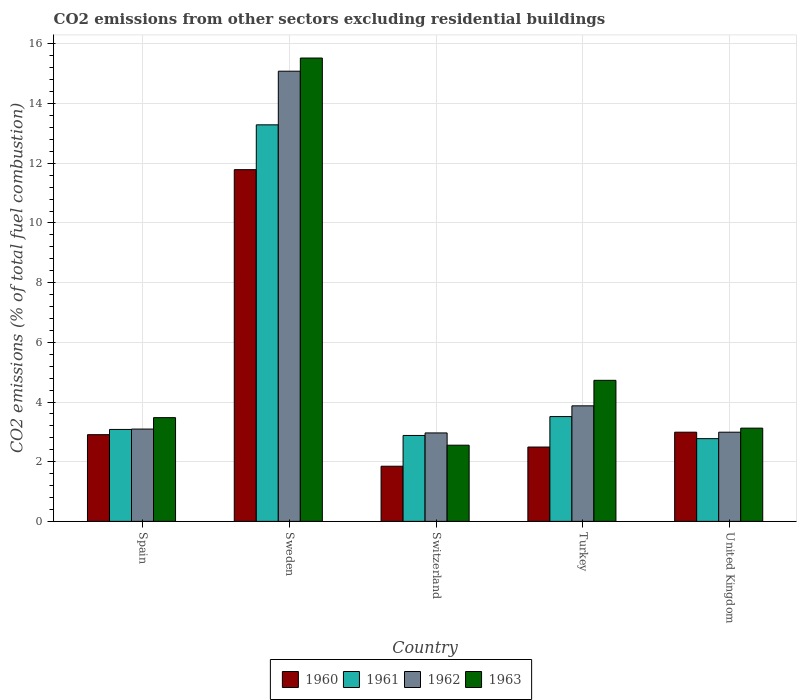How many groups of bars are there?
Your answer should be very brief. 5. Are the number of bars per tick equal to the number of legend labels?
Your response must be concise. Yes. Are the number of bars on each tick of the X-axis equal?
Give a very brief answer. Yes. How many bars are there on the 4th tick from the left?
Provide a short and direct response. 4. How many bars are there on the 2nd tick from the right?
Provide a short and direct response. 4. What is the label of the 1st group of bars from the left?
Provide a succinct answer. Spain. In how many cases, is the number of bars for a given country not equal to the number of legend labels?
Keep it short and to the point. 0. What is the total CO2 emitted in 1962 in Spain?
Ensure brevity in your answer.  3.09. Across all countries, what is the maximum total CO2 emitted in 1963?
Your answer should be compact. 15.53. Across all countries, what is the minimum total CO2 emitted in 1962?
Provide a succinct answer. 2.96. In which country was the total CO2 emitted in 1963 minimum?
Provide a succinct answer. Switzerland. What is the total total CO2 emitted in 1963 in the graph?
Your answer should be very brief. 29.41. What is the difference between the total CO2 emitted in 1962 in Spain and that in Switzerland?
Keep it short and to the point. 0.13. What is the difference between the total CO2 emitted in 1963 in United Kingdom and the total CO2 emitted in 1961 in Spain?
Ensure brevity in your answer.  0.04. What is the average total CO2 emitted in 1961 per country?
Your answer should be compact. 5.11. What is the difference between the total CO2 emitted of/in 1962 and total CO2 emitted of/in 1960 in United Kingdom?
Offer a very short reply. 1.3986663769838259e-5. In how many countries, is the total CO2 emitted in 1963 greater than 15.6?
Offer a very short reply. 0. What is the ratio of the total CO2 emitted in 1961 in Spain to that in United Kingdom?
Your answer should be very brief. 1.11. What is the difference between the highest and the second highest total CO2 emitted in 1961?
Offer a very short reply. -0.43. What is the difference between the highest and the lowest total CO2 emitted in 1963?
Provide a short and direct response. 12.97. In how many countries, is the total CO2 emitted in 1960 greater than the average total CO2 emitted in 1960 taken over all countries?
Provide a succinct answer. 1. What is the difference between two consecutive major ticks on the Y-axis?
Give a very brief answer. 2. Are the values on the major ticks of Y-axis written in scientific E-notation?
Keep it short and to the point. No. What is the title of the graph?
Your response must be concise. CO2 emissions from other sectors excluding residential buildings. What is the label or title of the X-axis?
Make the answer very short. Country. What is the label or title of the Y-axis?
Your answer should be very brief. CO2 emissions (% of total fuel combustion). What is the CO2 emissions (% of total fuel combustion) of 1960 in Spain?
Offer a very short reply. 2.91. What is the CO2 emissions (% of total fuel combustion) in 1961 in Spain?
Give a very brief answer. 3.08. What is the CO2 emissions (% of total fuel combustion) in 1962 in Spain?
Offer a very short reply. 3.09. What is the CO2 emissions (% of total fuel combustion) in 1963 in Spain?
Provide a short and direct response. 3.48. What is the CO2 emissions (% of total fuel combustion) in 1960 in Sweden?
Provide a succinct answer. 11.79. What is the CO2 emissions (% of total fuel combustion) in 1961 in Sweden?
Ensure brevity in your answer.  13.29. What is the CO2 emissions (% of total fuel combustion) in 1962 in Sweden?
Your response must be concise. 15.09. What is the CO2 emissions (% of total fuel combustion) in 1963 in Sweden?
Provide a short and direct response. 15.53. What is the CO2 emissions (% of total fuel combustion) of 1960 in Switzerland?
Make the answer very short. 1.85. What is the CO2 emissions (% of total fuel combustion) in 1961 in Switzerland?
Give a very brief answer. 2.88. What is the CO2 emissions (% of total fuel combustion) of 1962 in Switzerland?
Give a very brief answer. 2.96. What is the CO2 emissions (% of total fuel combustion) in 1963 in Switzerland?
Your answer should be very brief. 2.55. What is the CO2 emissions (% of total fuel combustion) of 1960 in Turkey?
Your response must be concise. 2.49. What is the CO2 emissions (% of total fuel combustion) of 1961 in Turkey?
Your answer should be very brief. 3.51. What is the CO2 emissions (% of total fuel combustion) of 1962 in Turkey?
Ensure brevity in your answer.  3.87. What is the CO2 emissions (% of total fuel combustion) of 1963 in Turkey?
Provide a short and direct response. 4.73. What is the CO2 emissions (% of total fuel combustion) of 1960 in United Kingdom?
Your answer should be compact. 2.99. What is the CO2 emissions (% of total fuel combustion) of 1961 in United Kingdom?
Provide a short and direct response. 2.77. What is the CO2 emissions (% of total fuel combustion) of 1962 in United Kingdom?
Offer a very short reply. 2.99. What is the CO2 emissions (% of total fuel combustion) of 1963 in United Kingdom?
Provide a succinct answer. 3.12. Across all countries, what is the maximum CO2 emissions (% of total fuel combustion) in 1960?
Your answer should be very brief. 11.79. Across all countries, what is the maximum CO2 emissions (% of total fuel combustion) in 1961?
Give a very brief answer. 13.29. Across all countries, what is the maximum CO2 emissions (% of total fuel combustion) in 1962?
Your answer should be compact. 15.09. Across all countries, what is the maximum CO2 emissions (% of total fuel combustion) of 1963?
Your answer should be very brief. 15.53. Across all countries, what is the minimum CO2 emissions (% of total fuel combustion) in 1960?
Make the answer very short. 1.85. Across all countries, what is the minimum CO2 emissions (% of total fuel combustion) in 1961?
Offer a terse response. 2.77. Across all countries, what is the minimum CO2 emissions (% of total fuel combustion) in 1962?
Your response must be concise. 2.96. Across all countries, what is the minimum CO2 emissions (% of total fuel combustion) in 1963?
Keep it short and to the point. 2.55. What is the total CO2 emissions (% of total fuel combustion) in 1960 in the graph?
Give a very brief answer. 22.02. What is the total CO2 emissions (% of total fuel combustion) in 1961 in the graph?
Your answer should be very brief. 25.53. What is the total CO2 emissions (% of total fuel combustion) of 1962 in the graph?
Give a very brief answer. 28. What is the total CO2 emissions (% of total fuel combustion) in 1963 in the graph?
Offer a very short reply. 29.41. What is the difference between the CO2 emissions (% of total fuel combustion) of 1960 in Spain and that in Sweden?
Give a very brief answer. -8.88. What is the difference between the CO2 emissions (% of total fuel combustion) in 1961 in Spain and that in Sweden?
Provide a short and direct response. -10.21. What is the difference between the CO2 emissions (% of total fuel combustion) of 1962 in Spain and that in Sweden?
Ensure brevity in your answer.  -11.99. What is the difference between the CO2 emissions (% of total fuel combustion) in 1963 in Spain and that in Sweden?
Offer a terse response. -12.05. What is the difference between the CO2 emissions (% of total fuel combustion) of 1960 in Spain and that in Switzerland?
Keep it short and to the point. 1.06. What is the difference between the CO2 emissions (% of total fuel combustion) in 1961 in Spain and that in Switzerland?
Provide a succinct answer. 0.2. What is the difference between the CO2 emissions (% of total fuel combustion) in 1962 in Spain and that in Switzerland?
Make the answer very short. 0.13. What is the difference between the CO2 emissions (% of total fuel combustion) of 1963 in Spain and that in Switzerland?
Your response must be concise. 0.92. What is the difference between the CO2 emissions (% of total fuel combustion) of 1960 in Spain and that in Turkey?
Provide a succinct answer. 0.41. What is the difference between the CO2 emissions (% of total fuel combustion) in 1961 in Spain and that in Turkey?
Provide a short and direct response. -0.43. What is the difference between the CO2 emissions (% of total fuel combustion) of 1962 in Spain and that in Turkey?
Give a very brief answer. -0.78. What is the difference between the CO2 emissions (% of total fuel combustion) of 1963 in Spain and that in Turkey?
Your answer should be very brief. -1.25. What is the difference between the CO2 emissions (% of total fuel combustion) of 1960 in Spain and that in United Kingdom?
Provide a succinct answer. -0.08. What is the difference between the CO2 emissions (% of total fuel combustion) of 1961 in Spain and that in United Kingdom?
Provide a short and direct response. 0.31. What is the difference between the CO2 emissions (% of total fuel combustion) of 1962 in Spain and that in United Kingdom?
Offer a terse response. 0.1. What is the difference between the CO2 emissions (% of total fuel combustion) in 1963 in Spain and that in United Kingdom?
Offer a very short reply. 0.35. What is the difference between the CO2 emissions (% of total fuel combustion) of 1960 in Sweden and that in Switzerland?
Keep it short and to the point. 9.94. What is the difference between the CO2 emissions (% of total fuel combustion) in 1961 in Sweden and that in Switzerland?
Your response must be concise. 10.41. What is the difference between the CO2 emissions (% of total fuel combustion) in 1962 in Sweden and that in Switzerland?
Give a very brief answer. 12.12. What is the difference between the CO2 emissions (% of total fuel combustion) in 1963 in Sweden and that in Switzerland?
Offer a very short reply. 12.97. What is the difference between the CO2 emissions (% of total fuel combustion) in 1960 in Sweden and that in Turkey?
Keep it short and to the point. 9.3. What is the difference between the CO2 emissions (% of total fuel combustion) of 1961 in Sweden and that in Turkey?
Offer a very short reply. 9.78. What is the difference between the CO2 emissions (% of total fuel combustion) in 1962 in Sweden and that in Turkey?
Keep it short and to the point. 11.21. What is the difference between the CO2 emissions (% of total fuel combustion) of 1963 in Sweden and that in Turkey?
Make the answer very short. 10.8. What is the difference between the CO2 emissions (% of total fuel combustion) in 1960 in Sweden and that in United Kingdom?
Keep it short and to the point. 8.8. What is the difference between the CO2 emissions (% of total fuel combustion) of 1961 in Sweden and that in United Kingdom?
Provide a short and direct response. 10.52. What is the difference between the CO2 emissions (% of total fuel combustion) of 1962 in Sweden and that in United Kingdom?
Provide a short and direct response. 12.1. What is the difference between the CO2 emissions (% of total fuel combustion) of 1963 in Sweden and that in United Kingdom?
Your answer should be very brief. 12.4. What is the difference between the CO2 emissions (% of total fuel combustion) in 1960 in Switzerland and that in Turkey?
Your response must be concise. -0.64. What is the difference between the CO2 emissions (% of total fuel combustion) of 1961 in Switzerland and that in Turkey?
Provide a succinct answer. -0.63. What is the difference between the CO2 emissions (% of total fuel combustion) in 1962 in Switzerland and that in Turkey?
Ensure brevity in your answer.  -0.91. What is the difference between the CO2 emissions (% of total fuel combustion) of 1963 in Switzerland and that in Turkey?
Give a very brief answer. -2.17. What is the difference between the CO2 emissions (% of total fuel combustion) in 1960 in Switzerland and that in United Kingdom?
Give a very brief answer. -1.14. What is the difference between the CO2 emissions (% of total fuel combustion) of 1961 in Switzerland and that in United Kingdom?
Offer a terse response. 0.11. What is the difference between the CO2 emissions (% of total fuel combustion) of 1962 in Switzerland and that in United Kingdom?
Ensure brevity in your answer.  -0.02. What is the difference between the CO2 emissions (% of total fuel combustion) of 1963 in Switzerland and that in United Kingdom?
Provide a succinct answer. -0.57. What is the difference between the CO2 emissions (% of total fuel combustion) in 1960 in Turkey and that in United Kingdom?
Your answer should be very brief. -0.5. What is the difference between the CO2 emissions (% of total fuel combustion) of 1961 in Turkey and that in United Kingdom?
Provide a short and direct response. 0.74. What is the difference between the CO2 emissions (% of total fuel combustion) in 1962 in Turkey and that in United Kingdom?
Make the answer very short. 0.88. What is the difference between the CO2 emissions (% of total fuel combustion) of 1963 in Turkey and that in United Kingdom?
Give a very brief answer. 1.6. What is the difference between the CO2 emissions (% of total fuel combustion) of 1960 in Spain and the CO2 emissions (% of total fuel combustion) of 1961 in Sweden?
Your answer should be compact. -10.38. What is the difference between the CO2 emissions (% of total fuel combustion) in 1960 in Spain and the CO2 emissions (% of total fuel combustion) in 1962 in Sweden?
Make the answer very short. -12.18. What is the difference between the CO2 emissions (% of total fuel combustion) of 1960 in Spain and the CO2 emissions (% of total fuel combustion) of 1963 in Sweden?
Offer a terse response. -12.62. What is the difference between the CO2 emissions (% of total fuel combustion) in 1961 in Spain and the CO2 emissions (% of total fuel combustion) in 1962 in Sweden?
Keep it short and to the point. -12.01. What is the difference between the CO2 emissions (% of total fuel combustion) in 1961 in Spain and the CO2 emissions (% of total fuel combustion) in 1963 in Sweden?
Offer a terse response. -12.45. What is the difference between the CO2 emissions (% of total fuel combustion) of 1962 in Spain and the CO2 emissions (% of total fuel combustion) of 1963 in Sweden?
Make the answer very short. -12.43. What is the difference between the CO2 emissions (% of total fuel combustion) in 1960 in Spain and the CO2 emissions (% of total fuel combustion) in 1961 in Switzerland?
Provide a short and direct response. 0.03. What is the difference between the CO2 emissions (% of total fuel combustion) in 1960 in Spain and the CO2 emissions (% of total fuel combustion) in 1962 in Switzerland?
Provide a short and direct response. -0.06. What is the difference between the CO2 emissions (% of total fuel combustion) of 1960 in Spain and the CO2 emissions (% of total fuel combustion) of 1963 in Switzerland?
Ensure brevity in your answer.  0.35. What is the difference between the CO2 emissions (% of total fuel combustion) in 1961 in Spain and the CO2 emissions (% of total fuel combustion) in 1962 in Switzerland?
Your answer should be very brief. 0.12. What is the difference between the CO2 emissions (% of total fuel combustion) of 1961 in Spain and the CO2 emissions (% of total fuel combustion) of 1963 in Switzerland?
Offer a terse response. 0.53. What is the difference between the CO2 emissions (% of total fuel combustion) in 1962 in Spain and the CO2 emissions (% of total fuel combustion) in 1963 in Switzerland?
Make the answer very short. 0.54. What is the difference between the CO2 emissions (% of total fuel combustion) of 1960 in Spain and the CO2 emissions (% of total fuel combustion) of 1961 in Turkey?
Your answer should be compact. -0.61. What is the difference between the CO2 emissions (% of total fuel combustion) of 1960 in Spain and the CO2 emissions (% of total fuel combustion) of 1962 in Turkey?
Your answer should be compact. -0.97. What is the difference between the CO2 emissions (% of total fuel combustion) in 1960 in Spain and the CO2 emissions (% of total fuel combustion) in 1963 in Turkey?
Offer a very short reply. -1.82. What is the difference between the CO2 emissions (% of total fuel combustion) of 1961 in Spain and the CO2 emissions (% of total fuel combustion) of 1962 in Turkey?
Keep it short and to the point. -0.79. What is the difference between the CO2 emissions (% of total fuel combustion) in 1961 in Spain and the CO2 emissions (% of total fuel combustion) in 1963 in Turkey?
Provide a succinct answer. -1.65. What is the difference between the CO2 emissions (% of total fuel combustion) in 1962 in Spain and the CO2 emissions (% of total fuel combustion) in 1963 in Turkey?
Provide a short and direct response. -1.63. What is the difference between the CO2 emissions (% of total fuel combustion) in 1960 in Spain and the CO2 emissions (% of total fuel combustion) in 1961 in United Kingdom?
Provide a short and direct response. 0.13. What is the difference between the CO2 emissions (% of total fuel combustion) in 1960 in Spain and the CO2 emissions (% of total fuel combustion) in 1962 in United Kingdom?
Ensure brevity in your answer.  -0.08. What is the difference between the CO2 emissions (% of total fuel combustion) of 1960 in Spain and the CO2 emissions (% of total fuel combustion) of 1963 in United Kingdom?
Your answer should be very brief. -0.22. What is the difference between the CO2 emissions (% of total fuel combustion) of 1961 in Spain and the CO2 emissions (% of total fuel combustion) of 1962 in United Kingdom?
Offer a very short reply. 0.09. What is the difference between the CO2 emissions (% of total fuel combustion) in 1961 in Spain and the CO2 emissions (% of total fuel combustion) in 1963 in United Kingdom?
Your answer should be very brief. -0.04. What is the difference between the CO2 emissions (% of total fuel combustion) of 1962 in Spain and the CO2 emissions (% of total fuel combustion) of 1963 in United Kingdom?
Your answer should be compact. -0.03. What is the difference between the CO2 emissions (% of total fuel combustion) in 1960 in Sweden and the CO2 emissions (% of total fuel combustion) in 1961 in Switzerland?
Keep it short and to the point. 8.91. What is the difference between the CO2 emissions (% of total fuel combustion) of 1960 in Sweden and the CO2 emissions (% of total fuel combustion) of 1962 in Switzerland?
Keep it short and to the point. 8.82. What is the difference between the CO2 emissions (% of total fuel combustion) of 1960 in Sweden and the CO2 emissions (% of total fuel combustion) of 1963 in Switzerland?
Keep it short and to the point. 9.23. What is the difference between the CO2 emissions (% of total fuel combustion) in 1961 in Sweden and the CO2 emissions (% of total fuel combustion) in 1962 in Switzerland?
Provide a short and direct response. 10.32. What is the difference between the CO2 emissions (% of total fuel combustion) in 1961 in Sweden and the CO2 emissions (% of total fuel combustion) in 1963 in Switzerland?
Provide a short and direct response. 10.74. What is the difference between the CO2 emissions (% of total fuel combustion) in 1962 in Sweden and the CO2 emissions (% of total fuel combustion) in 1963 in Switzerland?
Keep it short and to the point. 12.53. What is the difference between the CO2 emissions (% of total fuel combustion) in 1960 in Sweden and the CO2 emissions (% of total fuel combustion) in 1961 in Turkey?
Offer a very short reply. 8.27. What is the difference between the CO2 emissions (% of total fuel combustion) in 1960 in Sweden and the CO2 emissions (% of total fuel combustion) in 1962 in Turkey?
Your answer should be very brief. 7.91. What is the difference between the CO2 emissions (% of total fuel combustion) of 1960 in Sweden and the CO2 emissions (% of total fuel combustion) of 1963 in Turkey?
Provide a succinct answer. 7.06. What is the difference between the CO2 emissions (% of total fuel combustion) of 1961 in Sweden and the CO2 emissions (% of total fuel combustion) of 1962 in Turkey?
Offer a terse response. 9.42. What is the difference between the CO2 emissions (% of total fuel combustion) of 1961 in Sweden and the CO2 emissions (% of total fuel combustion) of 1963 in Turkey?
Offer a terse response. 8.56. What is the difference between the CO2 emissions (% of total fuel combustion) of 1962 in Sweden and the CO2 emissions (% of total fuel combustion) of 1963 in Turkey?
Offer a very short reply. 10.36. What is the difference between the CO2 emissions (% of total fuel combustion) in 1960 in Sweden and the CO2 emissions (% of total fuel combustion) in 1961 in United Kingdom?
Your answer should be compact. 9.01. What is the difference between the CO2 emissions (% of total fuel combustion) in 1960 in Sweden and the CO2 emissions (% of total fuel combustion) in 1962 in United Kingdom?
Your answer should be compact. 8.8. What is the difference between the CO2 emissions (% of total fuel combustion) of 1960 in Sweden and the CO2 emissions (% of total fuel combustion) of 1963 in United Kingdom?
Ensure brevity in your answer.  8.66. What is the difference between the CO2 emissions (% of total fuel combustion) of 1961 in Sweden and the CO2 emissions (% of total fuel combustion) of 1962 in United Kingdom?
Ensure brevity in your answer.  10.3. What is the difference between the CO2 emissions (% of total fuel combustion) of 1961 in Sweden and the CO2 emissions (% of total fuel combustion) of 1963 in United Kingdom?
Give a very brief answer. 10.16. What is the difference between the CO2 emissions (% of total fuel combustion) in 1962 in Sweden and the CO2 emissions (% of total fuel combustion) in 1963 in United Kingdom?
Give a very brief answer. 11.96. What is the difference between the CO2 emissions (% of total fuel combustion) in 1960 in Switzerland and the CO2 emissions (% of total fuel combustion) in 1961 in Turkey?
Offer a very short reply. -1.66. What is the difference between the CO2 emissions (% of total fuel combustion) in 1960 in Switzerland and the CO2 emissions (% of total fuel combustion) in 1962 in Turkey?
Ensure brevity in your answer.  -2.02. What is the difference between the CO2 emissions (% of total fuel combustion) in 1960 in Switzerland and the CO2 emissions (% of total fuel combustion) in 1963 in Turkey?
Offer a very short reply. -2.88. What is the difference between the CO2 emissions (% of total fuel combustion) in 1961 in Switzerland and the CO2 emissions (% of total fuel combustion) in 1962 in Turkey?
Give a very brief answer. -0.99. What is the difference between the CO2 emissions (% of total fuel combustion) in 1961 in Switzerland and the CO2 emissions (% of total fuel combustion) in 1963 in Turkey?
Keep it short and to the point. -1.85. What is the difference between the CO2 emissions (% of total fuel combustion) in 1962 in Switzerland and the CO2 emissions (% of total fuel combustion) in 1963 in Turkey?
Your response must be concise. -1.76. What is the difference between the CO2 emissions (% of total fuel combustion) of 1960 in Switzerland and the CO2 emissions (% of total fuel combustion) of 1961 in United Kingdom?
Ensure brevity in your answer.  -0.92. What is the difference between the CO2 emissions (% of total fuel combustion) of 1960 in Switzerland and the CO2 emissions (% of total fuel combustion) of 1962 in United Kingdom?
Make the answer very short. -1.14. What is the difference between the CO2 emissions (% of total fuel combustion) in 1960 in Switzerland and the CO2 emissions (% of total fuel combustion) in 1963 in United Kingdom?
Your answer should be compact. -1.28. What is the difference between the CO2 emissions (% of total fuel combustion) of 1961 in Switzerland and the CO2 emissions (% of total fuel combustion) of 1962 in United Kingdom?
Ensure brevity in your answer.  -0.11. What is the difference between the CO2 emissions (% of total fuel combustion) in 1961 in Switzerland and the CO2 emissions (% of total fuel combustion) in 1963 in United Kingdom?
Make the answer very short. -0.25. What is the difference between the CO2 emissions (% of total fuel combustion) in 1962 in Switzerland and the CO2 emissions (% of total fuel combustion) in 1963 in United Kingdom?
Give a very brief answer. -0.16. What is the difference between the CO2 emissions (% of total fuel combustion) of 1960 in Turkey and the CO2 emissions (% of total fuel combustion) of 1961 in United Kingdom?
Offer a very short reply. -0.28. What is the difference between the CO2 emissions (% of total fuel combustion) in 1960 in Turkey and the CO2 emissions (% of total fuel combustion) in 1962 in United Kingdom?
Make the answer very short. -0.5. What is the difference between the CO2 emissions (% of total fuel combustion) in 1960 in Turkey and the CO2 emissions (% of total fuel combustion) in 1963 in United Kingdom?
Offer a very short reply. -0.63. What is the difference between the CO2 emissions (% of total fuel combustion) in 1961 in Turkey and the CO2 emissions (% of total fuel combustion) in 1962 in United Kingdom?
Offer a very short reply. 0.52. What is the difference between the CO2 emissions (% of total fuel combustion) of 1961 in Turkey and the CO2 emissions (% of total fuel combustion) of 1963 in United Kingdom?
Your answer should be compact. 0.39. What is the difference between the CO2 emissions (% of total fuel combustion) of 1962 in Turkey and the CO2 emissions (% of total fuel combustion) of 1963 in United Kingdom?
Offer a very short reply. 0.75. What is the average CO2 emissions (% of total fuel combustion) of 1960 per country?
Keep it short and to the point. 4.4. What is the average CO2 emissions (% of total fuel combustion) in 1961 per country?
Keep it short and to the point. 5.11. What is the average CO2 emissions (% of total fuel combustion) in 1962 per country?
Give a very brief answer. 5.6. What is the average CO2 emissions (% of total fuel combustion) in 1963 per country?
Give a very brief answer. 5.88. What is the difference between the CO2 emissions (% of total fuel combustion) in 1960 and CO2 emissions (% of total fuel combustion) in 1961 in Spain?
Your answer should be compact. -0.17. What is the difference between the CO2 emissions (% of total fuel combustion) in 1960 and CO2 emissions (% of total fuel combustion) in 1962 in Spain?
Provide a succinct answer. -0.19. What is the difference between the CO2 emissions (% of total fuel combustion) of 1960 and CO2 emissions (% of total fuel combustion) of 1963 in Spain?
Your response must be concise. -0.57. What is the difference between the CO2 emissions (% of total fuel combustion) in 1961 and CO2 emissions (% of total fuel combustion) in 1962 in Spain?
Make the answer very short. -0.01. What is the difference between the CO2 emissions (% of total fuel combustion) of 1961 and CO2 emissions (% of total fuel combustion) of 1963 in Spain?
Make the answer very short. -0.4. What is the difference between the CO2 emissions (% of total fuel combustion) of 1962 and CO2 emissions (% of total fuel combustion) of 1963 in Spain?
Give a very brief answer. -0.38. What is the difference between the CO2 emissions (% of total fuel combustion) in 1960 and CO2 emissions (% of total fuel combustion) in 1961 in Sweden?
Your response must be concise. -1.5. What is the difference between the CO2 emissions (% of total fuel combustion) in 1960 and CO2 emissions (% of total fuel combustion) in 1962 in Sweden?
Your answer should be very brief. -3.3. What is the difference between the CO2 emissions (% of total fuel combustion) in 1960 and CO2 emissions (% of total fuel combustion) in 1963 in Sweden?
Keep it short and to the point. -3.74. What is the difference between the CO2 emissions (% of total fuel combustion) of 1961 and CO2 emissions (% of total fuel combustion) of 1962 in Sweden?
Your answer should be very brief. -1.8. What is the difference between the CO2 emissions (% of total fuel combustion) in 1961 and CO2 emissions (% of total fuel combustion) in 1963 in Sweden?
Provide a short and direct response. -2.24. What is the difference between the CO2 emissions (% of total fuel combustion) of 1962 and CO2 emissions (% of total fuel combustion) of 1963 in Sweden?
Your answer should be compact. -0.44. What is the difference between the CO2 emissions (% of total fuel combustion) in 1960 and CO2 emissions (% of total fuel combustion) in 1961 in Switzerland?
Offer a terse response. -1.03. What is the difference between the CO2 emissions (% of total fuel combustion) of 1960 and CO2 emissions (% of total fuel combustion) of 1962 in Switzerland?
Your answer should be compact. -1.12. What is the difference between the CO2 emissions (% of total fuel combustion) of 1960 and CO2 emissions (% of total fuel combustion) of 1963 in Switzerland?
Give a very brief answer. -0.7. What is the difference between the CO2 emissions (% of total fuel combustion) in 1961 and CO2 emissions (% of total fuel combustion) in 1962 in Switzerland?
Offer a very short reply. -0.08. What is the difference between the CO2 emissions (% of total fuel combustion) of 1961 and CO2 emissions (% of total fuel combustion) of 1963 in Switzerland?
Offer a terse response. 0.33. What is the difference between the CO2 emissions (% of total fuel combustion) of 1962 and CO2 emissions (% of total fuel combustion) of 1963 in Switzerland?
Make the answer very short. 0.41. What is the difference between the CO2 emissions (% of total fuel combustion) of 1960 and CO2 emissions (% of total fuel combustion) of 1961 in Turkey?
Keep it short and to the point. -1.02. What is the difference between the CO2 emissions (% of total fuel combustion) of 1960 and CO2 emissions (% of total fuel combustion) of 1962 in Turkey?
Provide a succinct answer. -1.38. What is the difference between the CO2 emissions (% of total fuel combustion) in 1960 and CO2 emissions (% of total fuel combustion) in 1963 in Turkey?
Make the answer very short. -2.24. What is the difference between the CO2 emissions (% of total fuel combustion) of 1961 and CO2 emissions (% of total fuel combustion) of 1962 in Turkey?
Your answer should be compact. -0.36. What is the difference between the CO2 emissions (% of total fuel combustion) of 1961 and CO2 emissions (% of total fuel combustion) of 1963 in Turkey?
Give a very brief answer. -1.21. What is the difference between the CO2 emissions (% of total fuel combustion) of 1962 and CO2 emissions (% of total fuel combustion) of 1963 in Turkey?
Provide a succinct answer. -0.85. What is the difference between the CO2 emissions (% of total fuel combustion) of 1960 and CO2 emissions (% of total fuel combustion) of 1961 in United Kingdom?
Your answer should be very brief. 0.22. What is the difference between the CO2 emissions (% of total fuel combustion) in 1960 and CO2 emissions (% of total fuel combustion) in 1963 in United Kingdom?
Provide a succinct answer. -0.14. What is the difference between the CO2 emissions (% of total fuel combustion) in 1961 and CO2 emissions (% of total fuel combustion) in 1962 in United Kingdom?
Provide a short and direct response. -0.22. What is the difference between the CO2 emissions (% of total fuel combustion) of 1961 and CO2 emissions (% of total fuel combustion) of 1963 in United Kingdom?
Ensure brevity in your answer.  -0.35. What is the difference between the CO2 emissions (% of total fuel combustion) in 1962 and CO2 emissions (% of total fuel combustion) in 1963 in United Kingdom?
Your response must be concise. -0.14. What is the ratio of the CO2 emissions (% of total fuel combustion) of 1960 in Spain to that in Sweden?
Provide a short and direct response. 0.25. What is the ratio of the CO2 emissions (% of total fuel combustion) of 1961 in Spain to that in Sweden?
Make the answer very short. 0.23. What is the ratio of the CO2 emissions (% of total fuel combustion) in 1962 in Spain to that in Sweden?
Give a very brief answer. 0.2. What is the ratio of the CO2 emissions (% of total fuel combustion) in 1963 in Spain to that in Sweden?
Provide a succinct answer. 0.22. What is the ratio of the CO2 emissions (% of total fuel combustion) in 1960 in Spain to that in Switzerland?
Keep it short and to the point. 1.57. What is the ratio of the CO2 emissions (% of total fuel combustion) in 1961 in Spain to that in Switzerland?
Offer a terse response. 1.07. What is the ratio of the CO2 emissions (% of total fuel combustion) of 1962 in Spain to that in Switzerland?
Keep it short and to the point. 1.04. What is the ratio of the CO2 emissions (% of total fuel combustion) of 1963 in Spain to that in Switzerland?
Give a very brief answer. 1.36. What is the ratio of the CO2 emissions (% of total fuel combustion) in 1960 in Spain to that in Turkey?
Ensure brevity in your answer.  1.17. What is the ratio of the CO2 emissions (% of total fuel combustion) in 1961 in Spain to that in Turkey?
Offer a very short reply. 0.88. What is the ratio of the CO2 emissions (% of total fuel combustion) of 1962 in Spain to that in Turkey?
Your answer should be compact. 0.8. What is the ratio of the CO2 emissions (% of total fuel combustion) in 1963 in Spain to that in Turkey?
Offer a very short reply. 0.74. What is the ratio of the CO2 emissions (% of total fuel combustion) in 1960 in Spain to that in United Kingdom?
Give a very brief answer. 0.97. What is the ratio of the CO2 emissions (% of total fuel combustion) in 1961 in Spain to that in United Kingdom?
Provide a succinct answer. 1.11. What is the ratio of the CO2 emissions (% of total fuel combustion) of 1962 in Spain to that in United Kingdom?
Ensure brevity in your answer.  1.03. What is the ratio of the CO2 emissions (% of total fuel combustion) in 1963 in Spain to that in United Kingdom?
Keep it short and to the point. 1.11. What is the ratio of the CO2 emissions (% of total fuel combustion) of 1960 in Sweden to that in Switzerland?
Make the answer very short. 6.38. What is the ratio of the CO2 emissions (% of total fuel combustion) of 1961 in Sweden to that in Switzerland?
Give a very brief answer. 4.62. What is the ratio of the CO2 emissions (% of total fuel combustion) in 1962 in Sweden to that in Switzerland?
Provide a succinct answer. 5.09. What is the ratio of the CO2 emissions (% of total fuel combustion) of 1963 in Sweden to that in Switzerland?
Your response must be concise. 6.08. What is the ratio of the CO2 emissions (% of total fuel combustion) in 1960 in Sweden to that in Turkey?
Make the answer very short. 4.73. What is the ratio of the CO2 emissions (% of total fuel combustion) in 1961 in Sweden to that in Turkey?
Give a very brief answer. 3.78. What is the ratio of the CO2 emissions (% of total fuel combustion) in 1962 in Sweden to that in Turkey?
Make the answer very short. 3.9. What is the ratio of the CO2 emissions (% of total fuel combustion) in 1963 in Sweden to that in Turkey?
Provide a short and direct response. 3.29. What is the ratio of the CO2 emissions (% of total fuel combustion) of 1960 in Sweden to that in United Kingdom?
Your answer should be compact. 3.94. What is the ratio of the CO2 emissions (% of total fuel combustion) in 1961 in Sweden to that in United Kingdom?
Give a very brief answer. 4.79. What is the ratio of the CO2 emissions (% of total fuel combustion) of 1962 in Sweden to that in United Kingdom?
Ensure brevity in your answer.  5.05. What is the ratio of the CO2 emissions (% of total fuel combustion) of 1963 in Sweden to that in United Kingdom?
Offer a very short reply. 4.97. What is the ratio of the CO2 emissions (% of total fuel combustion) of 1960 in Switzerland to that in Turkey?
Give a very brief answer. 0.74. What is the ratio of the CO2 emissions (% of total fuel combustion) of 1961 in Switzerland to that in Turkey?
Offer a terse response. 0.82. What is the ratio of the CO2 emissions (% of total fuel combustion) of 1962 in Switzerland to that in Turkey?
Provide a short and direct response. 0.77. What is the ratio of the CO2 emissions (% of total fuel combustion) in 1963 in Switzerland to that in Turkey?
Provide a succinct answer. 0.54. What is the ratio of the CO2 emissions (% of total fuel combustion) in 1960 in Switzerland to that in United Kingdom?
Ensure brevity in your answer.  0.62. What is the ratio of the CO2 emissions (% of total fuel combustion) in 1961 in Switzerland to that in United Kingdom?
Your answer should be compact. 1.04. What is the ratio of the CO2 emissions (% of total fuel combustion) of 1963 in Switzerland to that in United Kingdom?
Ensure brevity in your answer.  0.82. What is the ratio of the CO2 emissions (% of total fuel combustion) of 1960 in Turkey to that in United Kingdom?
Keep it short and to the point. 0.83. What is the ratio of the CO2 emissions (% of total fuel combustion) of 1961 in Turkey to that in United Kingdom?
Offer a terse response. 1.27. What is the ratio of the CO2 emissions (% of total fuel combustion) in 1962 in Turkey to that in United Kingdom?
Your answer should be very brief. 1.3. What is the ratio of the CO2 emissions (% of total fuel combustion) in 1963 in Turkey to that in United Kingdom?
Your response must be concise. 1.51. What is the difference between the highest and the second highest CO2 emissions (% of total fuel combustion) in 1960?
Make the answer very short. 8.8. What is the difference between the highest and the second highest CO2 emissions (% of total fuel combustion) of 1961?
Make the answer very short. 9.78. What is the difference between the highest and the second highest CO2 emissions (% of total fuel combustion) of 1962?
Provide a short and direct response. 11.21. What is the difference between the highest and the second highest CO2 emissions (% of total fuel combustion) of 1963?
Give a very brief answer. 10.8. What is the difference between the highest and the lowest CO2 emissions (% of total fuel combustion) in 1960?
Make the answer very short. 9.94. What is the difference between the highest and the lowest CO2 emissions (% of total fuel combustion) in 1961?
Offer a terse response. 10.52. What is the difference between the highest and the lowest CO2 emissions (% of total fuel combustion) in 1962?
Offer a very short reply. 12.12. What is the difference between the highest and the lowest CO2 emissions (% of total fuel combustion) in 1963?
Provide a succinct answer. 12.97. 